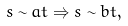<formula> <loc_0><loc_0><loc_500><loc_500>s \sim a t \Rightarrow s \sim b t ,</formula> 